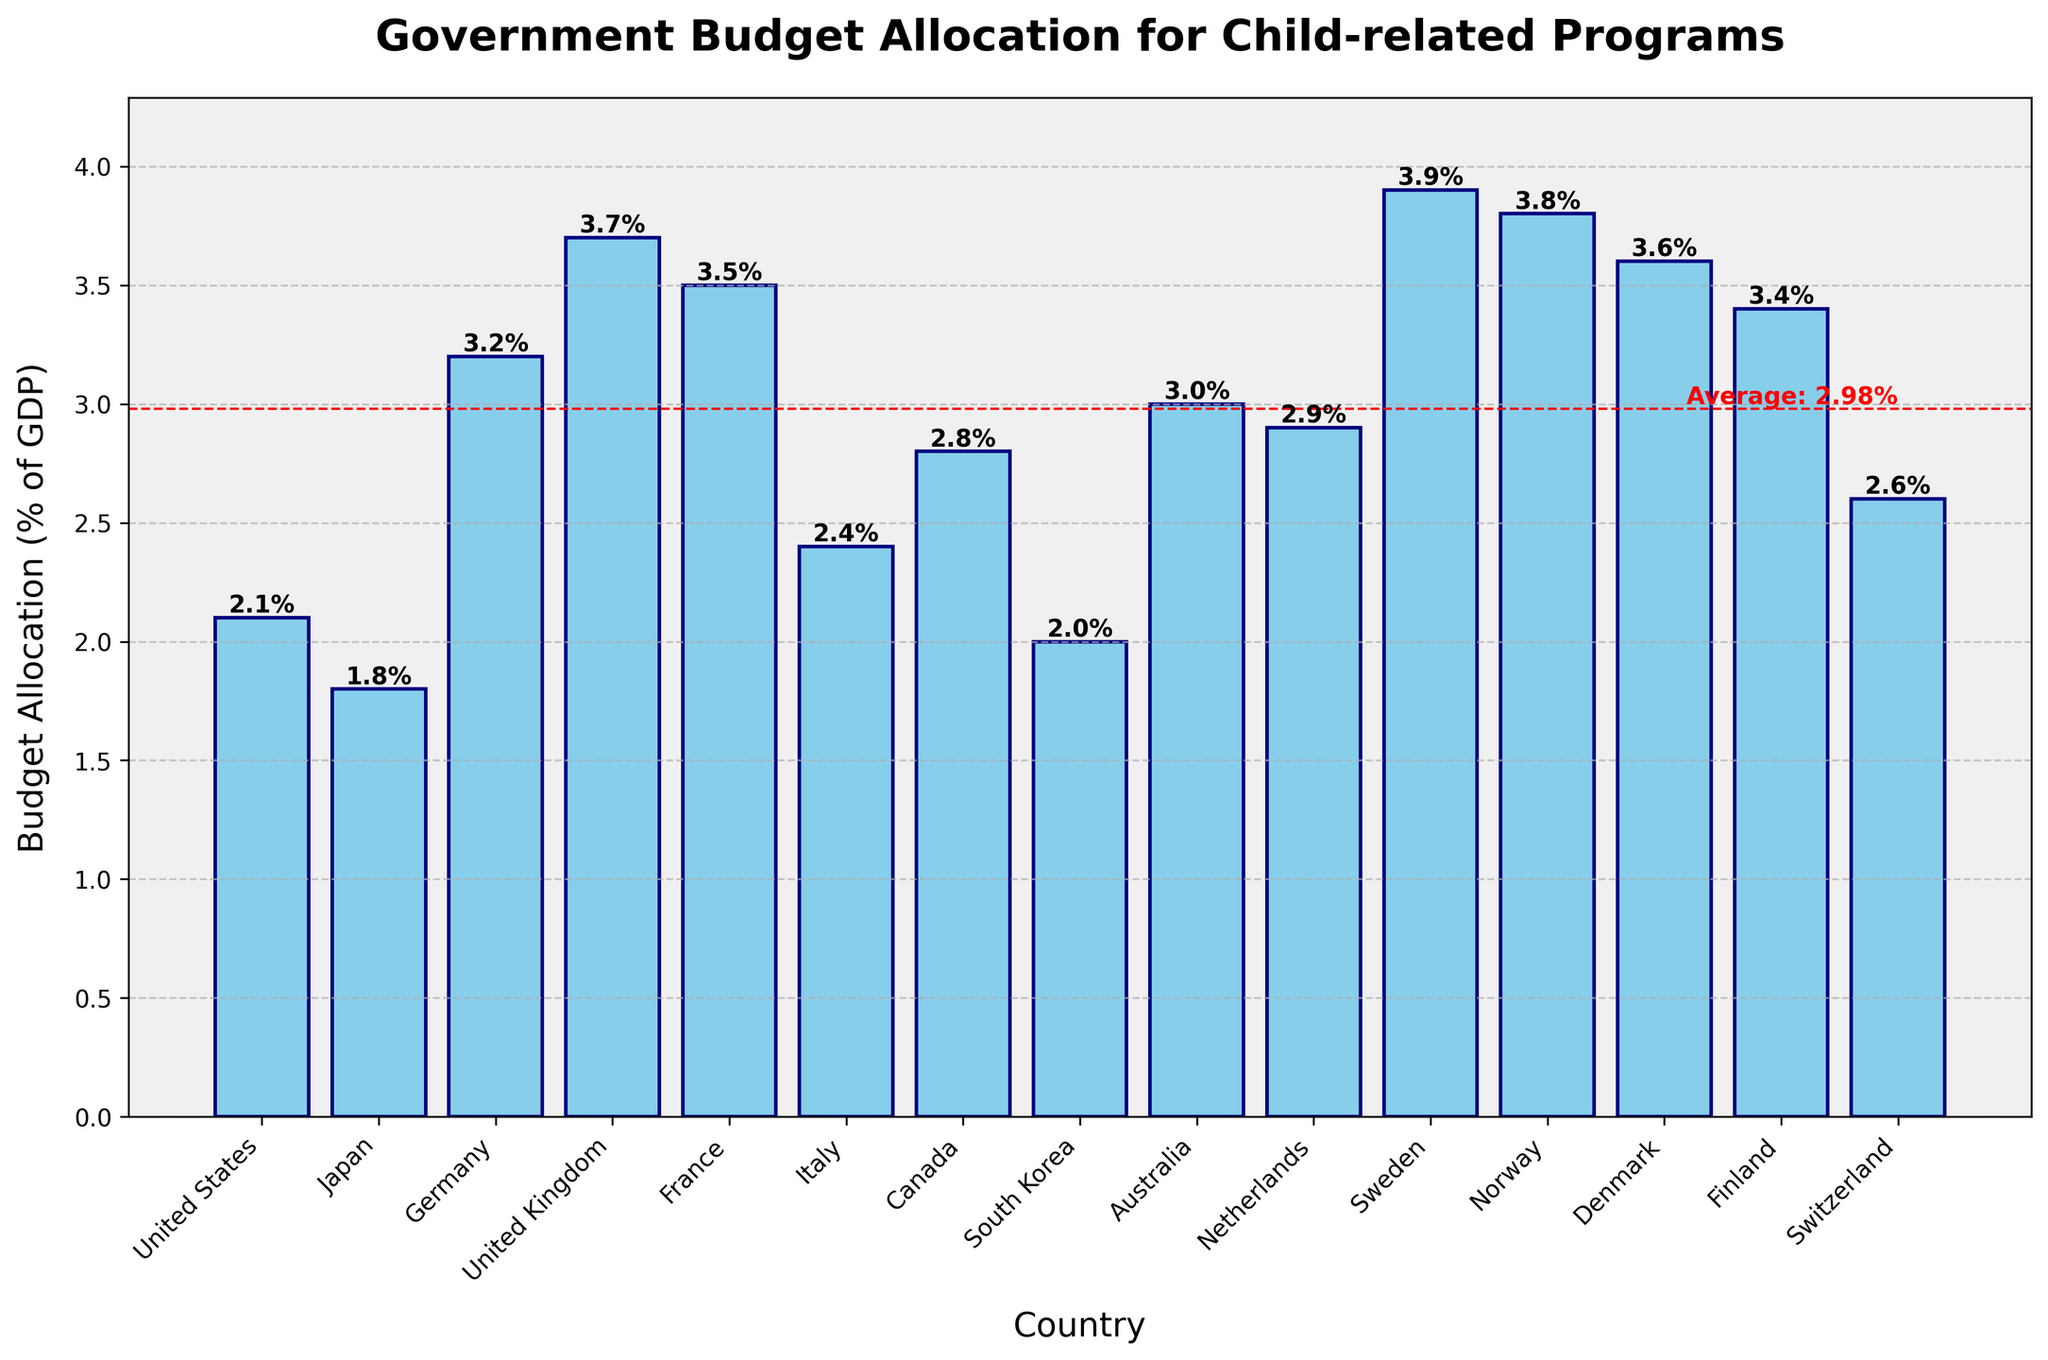Which country allocates the highest percentage of its GDP to child-related programs? The country with the tallest bar represents the highest allocation. In the figure, Sweden has the tallest bar.
Answer: Sweden How does Norway’s allocation compare to Finland’s? Look at the heights of the bars for Norway and Finland. Norway’s bar is slightly taller than Finland’s, indicating a higher allocation.
Answer: Norway has a higher allocation than Finland What is the average percentage of GDP allocated to child-related programs? The plot includes a horizontal red dashed line indicating the average. The value next to that line represents the average allocation.
Answer: 3.0% What is the difference between Sweden and the United States in terms of percentage of GDP allocated to child-related programs? Locate the heights of the bars for Sweden and the United States. Subtract the percentage for the United States (2.1%) from Sweden’s (3.9%).
Answer: 1.8% Which countries have a budget allocation greater than the average? Identify the bars that are taller than the red dashed horizontal line. These countries are the ones with higher-than-average allocations.
Answer: Germany, United Kingdom, France, Denmark, Finland, Sweden, Norway What is the range of the budget allocation percentages among the listed countries? The range is determined by subtracting the smallest allocation (Japan, 1.8%) from the largest allocation (Sweden, 3.9%).
Answer: 2.1% Which country has the closest budget allocation to the average? Find the bar that is closest in height to the red dashed horizontal line indicating the average allocation.
Answer: Australia How many countries allocate less than 2.5% of their GDP to child-related programs? Count the number of bars with heights less than the 2.5% mark. These countries are Japan, United States, South Korea, and Italy.
Answer: 4 Which countries allocate exactly 3% of their GDP to child-related programs? Identify bars with a height of 3%. Only Australia has a bar at this level.
Answer: Australia Compare the allocations of Canada and the Netherlands. Which country spends more? Examine the heights of the bars for Canada and the Netherlands. The bar for the Netherlands is slightly taller, indicating a higher allocation.
Answer: Netherlands 